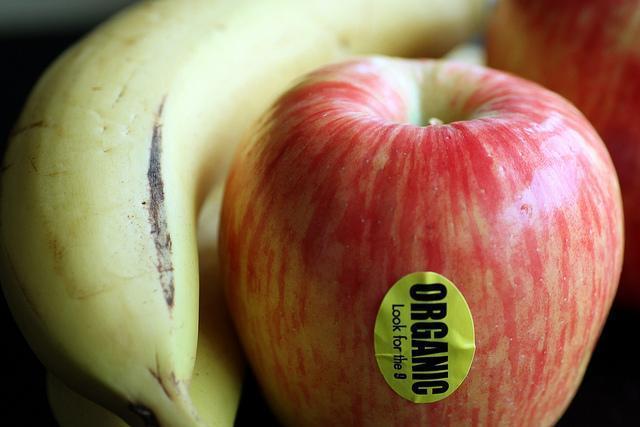How many apples are visible?
Give a very brief answer. 2. How many people are wearing black shirt?
Give a very brief answer. 0. 